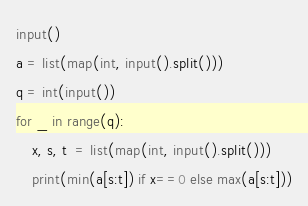Convert code to text. <code><loc_0><loc_0><loc_500><loc_500><_Python_>input()
a = list(map(int, input().split()))
q = int(input())
for _ in range(q):
	x, s, t  = list(map(int, input().split()))
	print(min(a[s:t]) if x==0 else max(a[s:t]))
</code> 